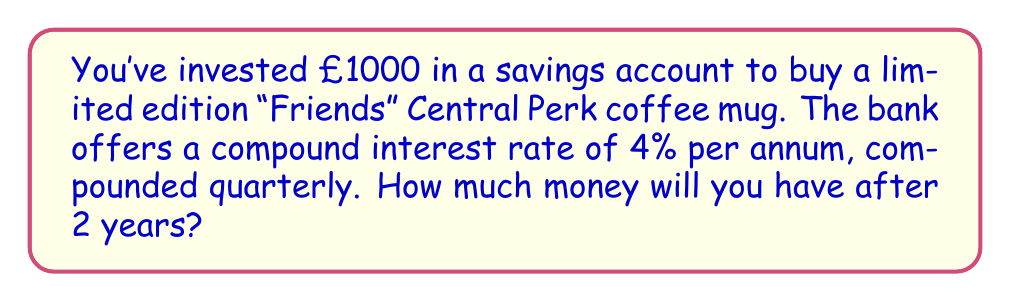Solve this math problem. Let's break this down step-by-step:

1) The formula for compound interest is:
   $A = P(1 + \frac{r}{n})^{nt}$

   Where:
   $A$ = Final amount
   $P$ = Principal (initial investment)
   $r$ = Annual interest rate (in decimal form)
   $n$ = Number of times interest is compounded per year
   $t$ = Number of years

2) We know:
   $P = £1000$
   $r = 4\% = 0.04$
   $n = 4$ (compounded quarterly)
   $t = 2$ years

3) Let's substitute these values into our formula:

   $A = 1000(1 + \frac{0.04}{4})^{4 \cdot 2}$

4) Simplify inside the parentheses:

   $A = 1000(1 + 0.01)^8$

5) Calculate the power:

   $A = 1000(1.01)^8 = 1000 \cdot 1.0829$

6) Multiply:

   $A = 1082.90$

Therefore, after 2 years, you will have £1082.90 in your savings account.
Answer: £1082.90 